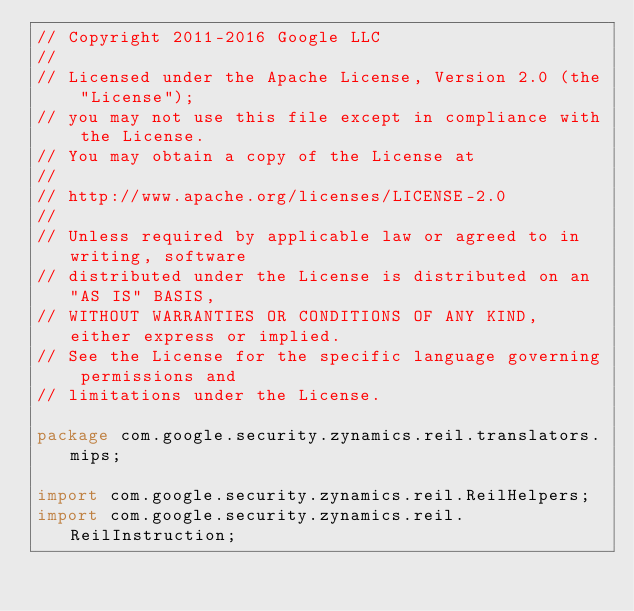<code> <loc_0><loc_0><loc_500><loc_500><_Java_>// Copyright 2011-2016 Google LLC
//
// Licensed under the Apache License, Version 2.0 (the "License");
// you may not use this file except in compliance with the License.
// You may obtain a copy of the License at
//
// http://www.apache.org/licenses/LICENSE-2.0
//
// Unless required by applicable law or agreed to in writing, software
// distributed under the License is distributed on an "AS IS" BASIS,
// WITHOUT WARRANTIES OR CONDITIONS OF ANY KIND, either express or implied.
// See the License for the specific language governing permissions and
// limitations under the License.

package com.google.security.zynamics.reil.translators.mips;

import com.google.security.zynamics.reil.ReilHelpers;
import com.google.security.zynamics.reil.ReilInstruction;</code> 